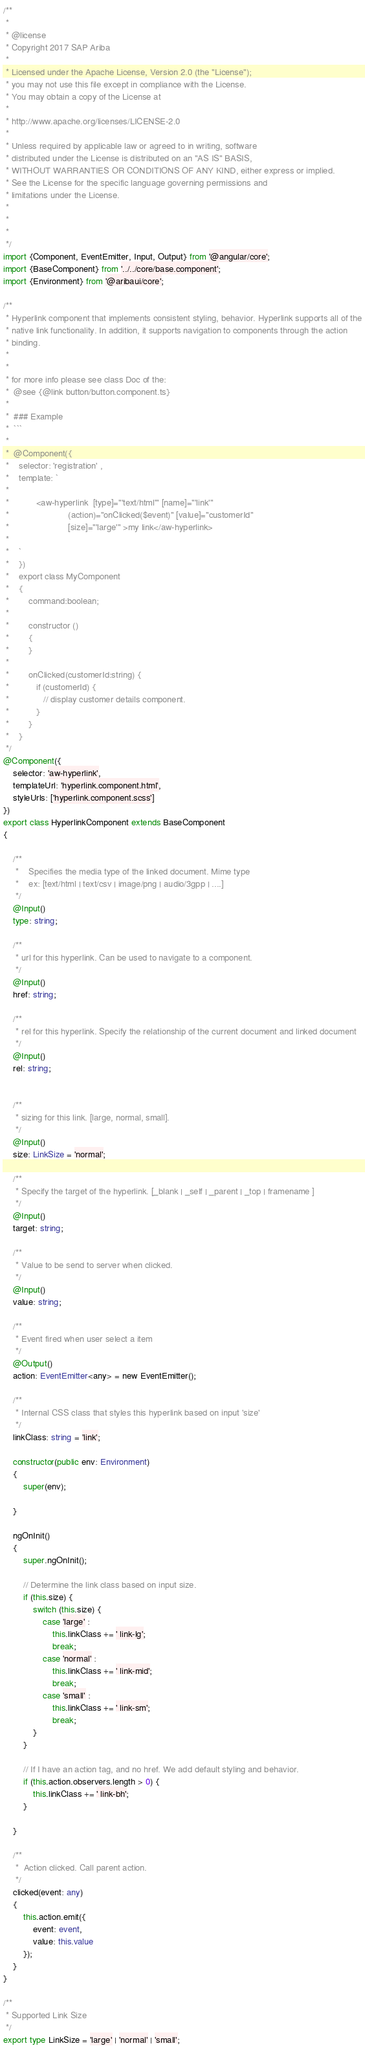<code> <loc_0><loc_0><loc_500><loc_500><_TypeScript_>/**
 *
 * @license
 * Copyright 2017 SAP Ariba
 *
 * Licensed under the Apache License, Version 2.0 (the "License");
 * you may not use this file except in compliance with the License.
 * You may obtain a copy of the License at
 *
 * http://www.apache.org/licenses/LICENSE-2.0
 *
 * Unless required by applicable law or agreed to in writing, software
 * distributed under the License is distributed on an "AS IS" BASIS,
 * WITHOUT WARRANTIES OR CONDITIONS OF ANY KIND, either express or implied.
 * See the License for the specific language governing permissions and
 * limitations under the License.
 *
 *
 *
 */
import {Component, EventEmitter, Input, Output} from '@angular/core';
import {BaseComponent} from '../../core/base.component';
import {Environment} from '@aribaui/core';

/**
 * Hyperlink component that implements consistent styling, behavior. Hyperlink supports all of the
 * native link functionality. In addition, it supports navigation to components through the action
 * binding.
 *
 *
 * for more info please see class Doc of the:
 *  @see {@link button/button.component.ts}
 *
 *  ### Example
 *  ```
 *
 *  @Component({
 *    selector: 'registration' ,
 *    template: `
 *
 *           <aw-hyperlink  [type]="'text/html'" [name]="'link'"
 *                        (action)="onClicked($event)" [value]="customerId"
 *                        [size]="'large'" >my link</aw-hyperlink>
 *
 *    `
 *    })
 *    export class MyComponent
 *    {
 *        command:boolean;
 *
 *        constructor ()
 *        {
 *        }
 *
 *        onClicked(customerId:string) {
 *           if (customerId) {
 *              // display customer details component.
 *           }
 *        }
 *    }
 */
@Component({
    selector: 'aw-hyperlink',
    templateUrl: 'hyperlink.component.html',
    styleUrls: ['hyperlink.component.scss']
})
export class HyperlinkComponent extends BaseComponent
{

    /**
     *    Specifies the media type of the linked document. Mime type
     *    ex: [text/html | text/csv | image/png | audio/3gpp | ....]
     */
    @Input()
    type: string;

    /**
     * url for this hyperlink. Can be used to navigate to a component.
     */
    @Input()
    href: string;

    /**
     * rel for this hyperlink. Specify the relationship of the current document and linked document
     */
    @Input()
    rel: string;


    /**
     * sizing for this link. [large, normal, small].
     */
    @Input()
    size: LinkSize = 'normal';

    /**
     * Specify the target of the hyperlink. [_blank | _self | _parent | _top | framename ]
     */
    @Input()
    target: string;

    /**
     * Value to be send to server when clicked.
     */
    @Input()
    value: string;

    /**
     * Event fired when user select a item
     */
    @Output()
    action: EventEmitter<any> = new EventEmitter();

    /**
     * Internal CSS class that styles this hyperlink based on input 'size'
     */
    linkClass: string = 'link';

    constructor(public env: Environment)
    {
        super(env);

    }

    ngOnInit()
    {
        super.ngOnInit();

        // Determine the link class based on input size.
        if (this.size) {
            switch (this.size) {
                case 'large' :
                    this.linkClass += ' link-lg';
                    break;
                case 'normal' :
                    this.linkClass += ' link-mid';
                    break;
                case 'small' :
                    this.linkClass += ' link-sm';
                    break;
            }
        }

        // If I have an action tag, and no href. We add default styling and behavior.
        if (this.action.observers.length > 0) {
            this.linkClass += ' link-bh';
        }

    }

    /**
     *  Action clicked. Call parent action.
     */
    clicked(event: any)
    {
        this.action.emit({
            event: event,
            value: this.value
        });
    }
}

/**
 * Supported Link Size
 */
export type LinkSize = 'large' | 'normal' | 'small';
</code> 